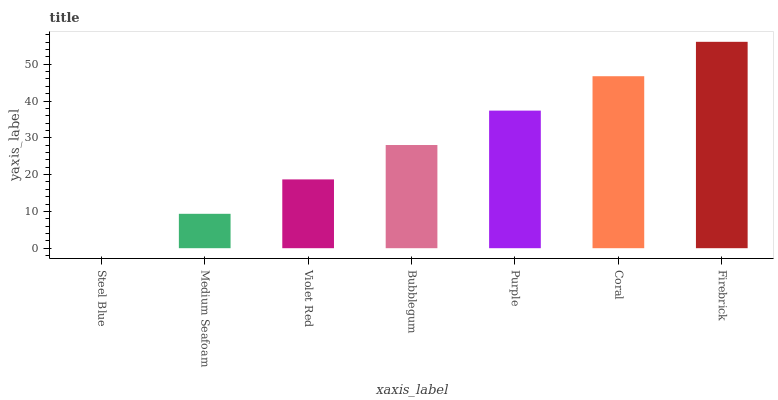Is Steel Blue the minimum?
Answer yes or no. Yes. Is Firebrick the maximum?
Answer yes or no. Yes. Is Medium Seafoam the minimum?
Answer yes or no. No. Is Medium Seafoam the maximum?
Answer yes or no. No. Is Medium Seafoam greater than Steel Blue?
Answer yes or no. Yes. Is Steel Blue less than Medium Seafoam?
Answer yes or no. Yes. Is Steel Blue greater than Medium Seafoam?
Answer yes or no. No. Is Medium Seafoam less than Steel Blue?
Answer yes or no. No. Is Bubblegum the high median?
Answer yes or no. Yes. Is Bubblegum the low median?
Answer yes or no. Yes. Is Coral the high median?
Answer yes or no. No. Is Medium Seafoam the low median?
Answer yes or no. No. 